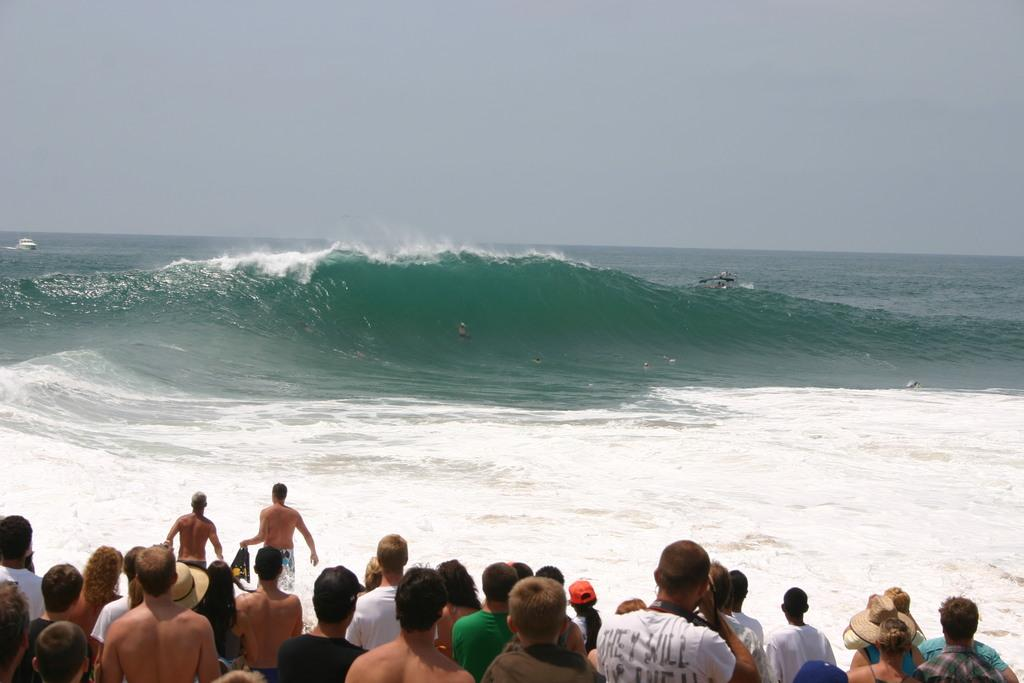Who or what can be seen in the image? There are people and boats in the image. Can you describe the person in the sea? Yes, there is a person in the sea. What else is present in the image besides people and boats? There is no additional information provided about the image. What type of hat is the person in the sea wearing? There is no information about a hat in the image, so it cannot be determined if the person is wearing one. 